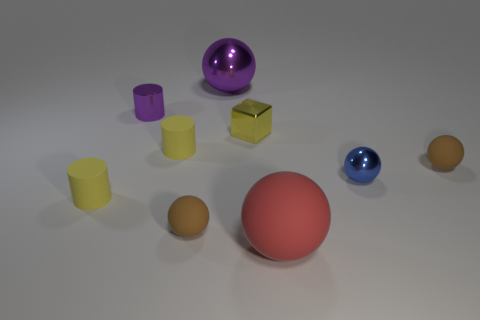There is a big metallic thing that is the same color as the metallic cylinder; what shape is it?
Provide a succinct answer. Sphere. There is a purple object that is the same shape as the red matte thing; what is it made of?
Keep it short and to the point. Metal. How many other objects are the same shape as the blue thing?
Give a very brief answer. 4. What shape is the red thing?
Keep it short and to the point. Sphere. Does the blue thing have the same material as the red object?
Provide a short and direct response. No. Are there the same number of tiny purple metal things that are to the left of the large rubber thing and purple balls left of the large metallic object?
Offer a very short reply. No. Are there any matte objects behind the small matte sphere that is behind the tiny matte sphere on the left side of the large purple object?
Provide a short and direct response. Yes. Is the yellow metal block the same size as the purple cylinder?
Keep it short and to the point. Yes. What is the color of the small block that is behind the brown rubber object on the left side of the brown ball behind the tiny blue metallic sphere?
Your answer should be compact. Yellow. How many tiny matte things are the same color as the big matte object?
Offer a very short reply. 0. 